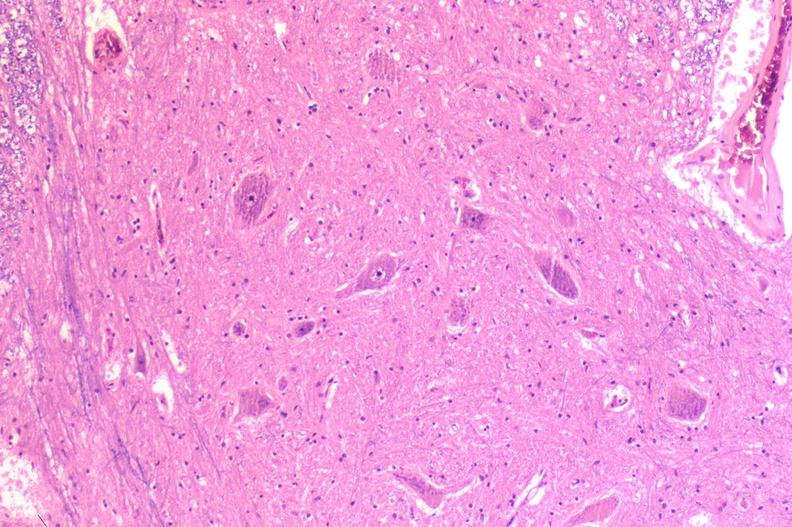what is present?
Answer the question using a single word or phrase. Nervous 